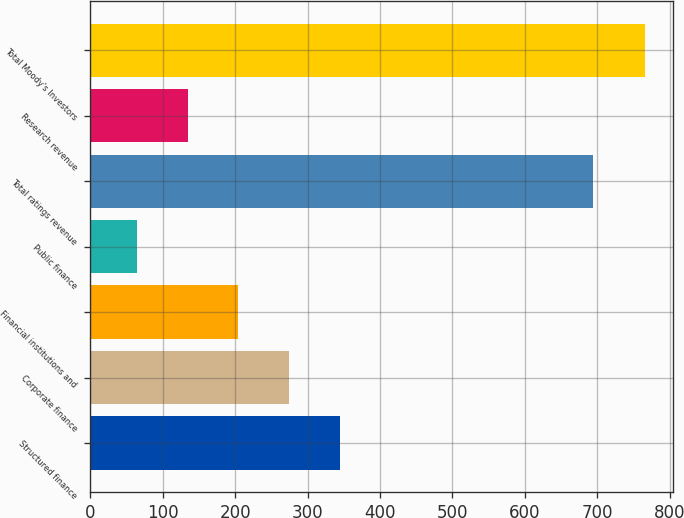<chart> <loc_0><loc_0><loc_500><loc_500><bar_chart><fcel>Structured finance<fcel>Corporate finance<fcel>Financial institutions and<fcel>Public finance<fcel>Total ratings revenue<fcel>Research revenue<fcel>Total Moody's Investors<nl><fcel>344.88<fcel>274.71<fcel>204.54<fcel>64.2<fcel>694.4<fcel>134.37<fcel>765.9<nl></chart> 